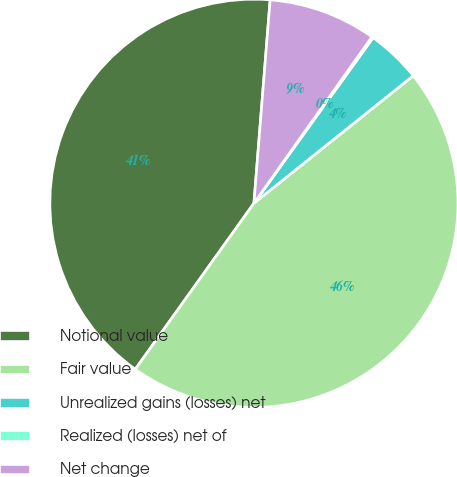<chart> <loc_0><loc_0><loc_500><loc_500><pie_chart><fcel>Notional value<fcel>Fair value<fcel>Unrealized gains (losses) net<fcel>Realized (losses) net of<fcel>Net change<nl><fcel>41.39%<fcel>45.62%<fcel>4.33%<fcel>0.11%<fcel>8.55%<nl></chart> 